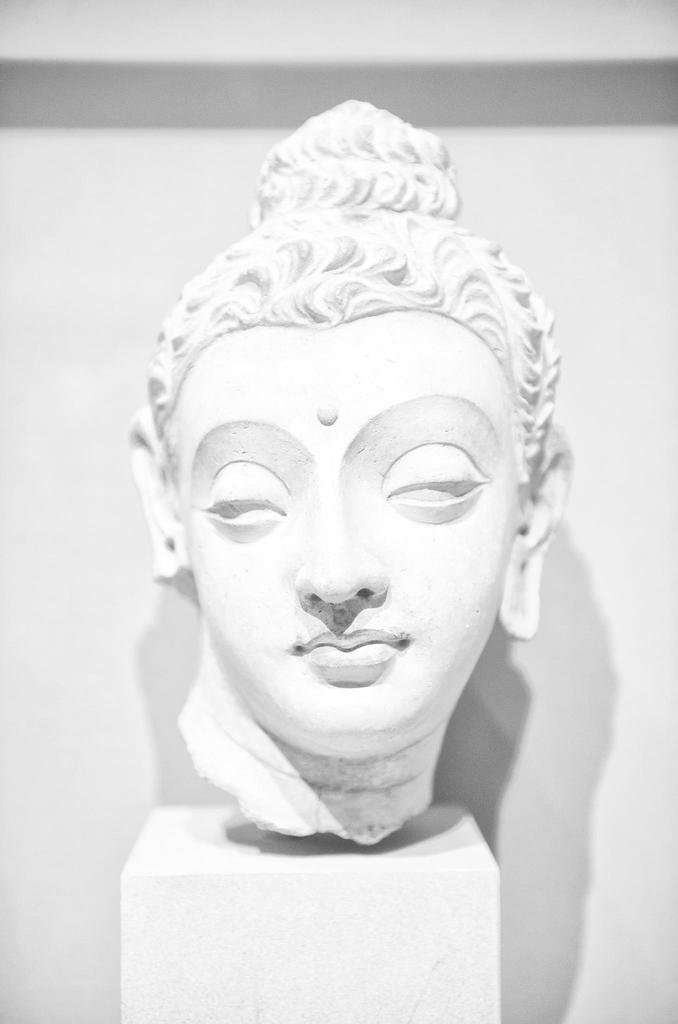What is the main subject of the image? There is a sculpture in the image. Can you describe the appearance of the sculpture? The sculpture is white in color. Where is the library located in the image? There is no library present in the image; it only features a white sculpture. What type of skirt is worn by the sculpture in the image? The sculpture is not a person and does not wear clothing, so there is no skirt present in the image. 